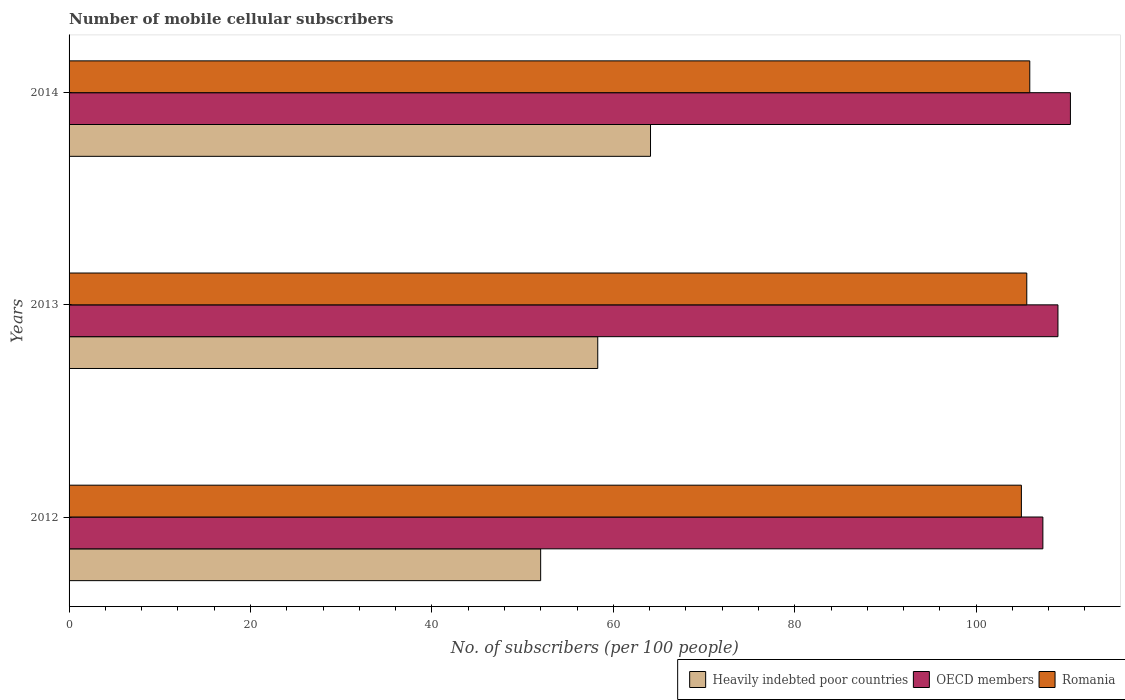How many different coloured bars are there?
Keep it short and to the point. 3. Are the number of bars on each tick of the Y-axis equal?
Give a very brief answer. Yes. How many bars are there on the 2nd tick from the top?
Offer a terse response. 3. What is the label of the 1st group of bars from the top?
Ensure brevity in your answer.  2014. What is the number of mobile cellular subscribers in OECD members in 2012?
Your answer should be compact. 107.36. Across all years, what is the maximum number of mobile cellular subscribers in Heavily indebted poor countries?
Ensure brevity in your answer.  64.1. Across all years, what is the minimum number of mobile cellular subscribers in Heavily indebted poor countries?
Provide a short and direct response. 51.99. What is the total number of mobile cellular subscribers in Heavily indebted poor countries in the graph?
Provide a succinct answer. 174.38. What is the difference between the number of mobile cellular subscribers in Heavily indebted poor countries in 2012 and that in 2014?
Keep it short and to the point. -12.11. What is the difference between the number of mobile cellular subscribers in Heavily indebted poor countries in 2014 and the number of mobile cellular subscribers in Romania in 2013?
Keep it short and to the point. -41.48. What is the average number of mobile cellular subscribers in Romania per year?
Offer a terse response. 105.5. In the year 2013, what is the difference between the number of mobile cellular subscribers in Heavily indebted poor countries and number of mobile cellular subscribers in Romania?
Offer a very short reply. -47.3. In how many years, is the number of mobile cellular subscribers in OECD members greater than 92 ?
Make the answer very short. 3. What is the ratio of the number of mobile cellular subscribers in Romania in 2013 to that in 2014?
Offer a very short reply. 1. What is the difference between the highest and the second highest number of mobile cellular subscribers in Romania?
Provide a short and direct response. 0.33. What is the difference between the highest and the lowest number of mobile cellular subscribers in Heavily indebted poor countries?
Give a very brief answer. 12.11. What does the 1st bar from the top in 2014 represents?
Keep it short and to the point. Romania. Are all the bars in the graph horizontal?
Your answer should be very brief. Yes. How many years are there in the graph?
Your answer should be very brief. 3. Are the values on the major ticks of X-axis written in scientific E-notation?
Your response must be concise. No. Does the graph contain any zero values?
Your answer should be compact. No. Does the graph contain grids?
Give a very brief answer. No. How many legend labels are there?
Keep it short and to the point. 3. How are the legend labels stacked?
Provide a succinct answer. Horizontal. What is the title of the graph?
Keep it short and to the point. Number of mobile cellular subscribers. Does "Slovenia" appear as one of the legend labels in the graph?
Provide a succinct answer. No. What is the label or title of the X-axis?
Provide a succinct answer. No. of subscribers (per 100 people). What is the label or title of the Y-axis?
Offer a very short reply. Years. What is the No. of subscribers (per 100 people) in Heavily indebted poor countries in 2012?
Offer a very short reply. 51.99. What is the No. of subscribers (per 100 people) of OECD members in 2012?
Your answer should be compact. 107.36. What is the No. of subscribers (per 100 people) of Romania in 2012?
Offer a terse response. 104.99. What is the No. of subscribers (per 100 people) in Heavily indebted poor countries in 2013?
Give a very brief answer. 58.28. What is the No. of subscribers (per 100 people) in OECD members in 2013?
Offer a terse response. 109.02. What is the No. of subscribers (per 100 people) in Romania in 2013?
Make the answer very short. 105.58. What is the No. of subscribers (per 100 people) in Heavily indebted poor countries in 2014?
Offer a very short reply. 64.1. What is the No. of subscribers (per 100 people) of OECD members in 2014?
Your response must be concise. 110.39. What is the No. of subscribers (per 100 people) of Romania in 2014?
Make the answer very short. 105.91. Across all years, what is the maximum No. of subscribers (per 100 people) in Heavily indebted poor countries?
Offer a terse response. 64.1. Across all years, what is the maximum No. of subscribers (per 100 people) in OECD members?
Give a very brief answer. 110.39. Across all years, what is the maximum No. of subscribers (per 100 people) of Romania?
Offer a very short reply. 105.91. Across all years, what is the minimum No. of subscribers (per 100 people) in Heavily indebted poor countries?
Your answer should be compact. 51.99. Across all years, what is the minimum No. of subscribers (per 100 people) in OECD members?
Offer a very short reply. 107.36. Across all years, what is the minimum No. of subscribers (per 100 people) in Romania?
Provide a succinct answer. 104.99. What is the total No. of subscribers (per 100 people) in Heavily indebted poor countries in the graph?
Your response must be concise. 174.38. What is the total No. of subscribers (per 100 people) in OECD members in the graph?
Offer a terse response. 326.77. What is the total No. of subscribers (per 100 people) of Romania in the graph?
Provide a short and direct response. 316.49. What is the difference between the No. of subscribers (per 100 people) of Heavily indebted poor countries in 2012 and that in 2013?
Keep it short and to the point. -6.3. What is the difference between the No. of subscribers (per 100 people) in OECD members in 2012 and that in 2013?
Make the answer very short. -1.66. What is the difference between the No. of subscribers (per 100 people) of Romania in 2012 and that in 2013?
Make the answer very short. -0.59. What is the difference between the No. of subscribers (per 100 people) of Heavily indebted poor countries in 2012 and that in 2014?
Provide a succinct answer. -12.11. What is the difference between the No. of subscribers (per 100 people) in OECD members in 2012 and that in 2014?
Give a very brief answer. -3.04. What is the difference between the No. of subscribers (per 100 people) in Romania in 2012 and that in 2014?
Offer a very short reply. -0.93. What is the difference between the No. of subscribers (per 100 people) in Heavily indebted poor countries in 2013 and that in 2014?
Ensure brevity in your answer.  -5.82. What is the difference between the No. of subscribers (per 100 people) of OECD members in 2013 and that in 2014?
Provide a short and direct response. -1.37. What is the difference between the No. of subscribers (per 100 people) of Romania in 2013 and that in 2014?
Make the answer very short. -0.33. What is the difference between the No. of subscribers (per 100 people) of Heavily indebted poor countries in 2012 and the No. of subscribers (per 100 people) of OECD members in 2013?
Your answer should be very brief. -57.03. What is the difference between the No. of subscribers (per 100 people) in Heavily indebted poor countries in 2012 and the No. of subscribers (per 100 people) in Romania in 2013?
Make the answer very short. -53.59. What is the difference between the No. of subscribers (per 100 people) of OECD members in 2012 and the No. of subscribers (per 100 people) of Romania in 2013?
Your response must be concise. 1.78. What is the difference between the No. of subscribers (per 100 people) of Heavily indebted poor countries in 2012 and the No. of subscribers (per 100 people) of OECD members in 2014?
Offer a very short reply. -58.4. What is the difference between the No. of subscribers (per 100 people) in Heavily indebted poor countries in 2012 and the No. of subscribers (per 100 people) in Romania in 2014?
Make the answer very short. -53.92. What is the difference between the No. of subscribers (per 100 people) of OECD members in 2012 and the No. of subscribers (per 100 people) of Romania in 2014?
Offer a very short reply. 1.44. What is the difference between the No. of subscribers (per 100 people) of Heavily indebted poor countries in 2013 and the No. of subscribers (per 100 people) of OECD members in 2014?
Your answer should be compact. -52.11. What is the difference between the No. of subscribers (per 100 people) in Heavily indebted poor countries in 2013 and the No. of subscribers (per 100 people) in Romania in 2014?
Your response must be concise. -47.63. What is the difference between the No. of subscribers (per 100 people) in OECD members in 2013 and the No. of subscribers (per 100 people) in Romania in 2014?
Provide a short and direct response. 3.11. What is the average No. of subscribers (per 100 people) of Heavily indebted poor countries per year?
Give a very brief answer. 58.13. What is the average No. of subscribers (per 100 people) in OECD members per year?
Your answer should be very brief. 108.92. What is the average No. of subscribers (per 100 people) in Romania per year?
Make the answer very short. 105.5. In the year 2012, what is the difference between the No. of subscribers (per 100 people) of Heavily indebted poor countries and No. of subscribers (per 100 people) of OECD members?
Give a very brief answer. -55.37. In the year 2012, what is the difference between the No. of subscribers (per 100 people) in Heavily indebted poor countries and No. of subscribers (per 100 people) in Romania?
Keep it short and to the point. -53. In the year 2012, what is the difference between the No. of subscribers (per 100 people) in OECD members and No. of subscribers (per 100 people) in Romania?
Offer a terse response. 2.37. In the year 2013, what is the difference between the No. of subscribers (per 100 people) in Heavily indebted poor countries and No. of subscribers (per 100 people) in OECD members?
Your response must be concise. -50.74. In the year 2013, what is the difference between the No. of subscribers (per 100 people) in Heavily indebted poor countries and No. of subscribers (per 100 people) in Romania?
Give a very brief answer. -47.3. In the year 2013, what is the difference between the No. of subscribers (per 100 people) in OECD members and No. of subscribers (per 100 people) in Romania?
Provide a short and direct response. 3.44. In the year 2014, what is the difference between the No. of subscribers (per 100 people) in Heavily indebted poor countries and No. of subscribers (per 100 people) in OECD members?
Make the answer very short. -46.29. In the year 2014, what is the difference between the No. of subscribers (per 100 people) in Heavily indebted poor countries and No. of subscribers (per 100 people) in Romania?
Keep it short and to the point. -41.81. In the year 2014, what is the difference between the No. of subscribers (per 100 people) of OECD members and No. of subscribers (per 100 people) of Romania?
Offer a terse response. 4.48. What is the ratio of the No. of subscribers (per 100 people) of Heavily indebted poor countries in 2012 to that in 2013?
Provide a short and direct response. 0.89. What is the ratio of the No. of subscribers (per 100 people) in Romania in 2012 to that in 2013?
Your answer should be very brief. 0.99. What is the ratio of the No. of subscribers (per 100 people) in Heavily indebted poor countries in 2012 to that in 2014?
Your answer should be compact. 0.81. What is the ratio of the No. of subscribers (per 100 people) in OECD members in 2012 to that in 2014?
Offer a very short reply. 0.97. What is the ratio of the No. of subscribers (per 100 people) of Romania in 2012 to that in 2014?
Your response must be concise. 0.99. What is the ratio of the No. of subscribers (per 100 people) of Heavily indebted poor countries in 2013 to that in 2014?
Your answer should be very brief. 0.91. What is the ratio of the No. of subscribers (per 100 people) of OECD members in 2013 to that in 2014?
Offer a very short reply. 0.99. What is the difference between the highest and the second highest No. of subscribers (per 100 people) of Heavily indebted poor countries?
Offer a very short reply. 5.82. What is the difference between the highest and the second highest No. of subscribers (per 100 people) in OECD members?
Make the answer very short. 1.37. What is the difference between the highest and the second highest No. of subscribers (per 100 people) of Romania?
Offer a terse response. 0.33. What is the difference between the highest and the lowest No. of subscribers (per 100 people) of Heavily indebted poor countries?
Your answer should be compact. 12.11. What is the difference between the highest and the lowest No. of subscribers (per 100 people) of OECD members?
Offer a terse response. 3.04. What is the difference between the highest and the lowest No. of subscribers (per 100 people) of Romania?
Your answer should be very brief. 0.93. 